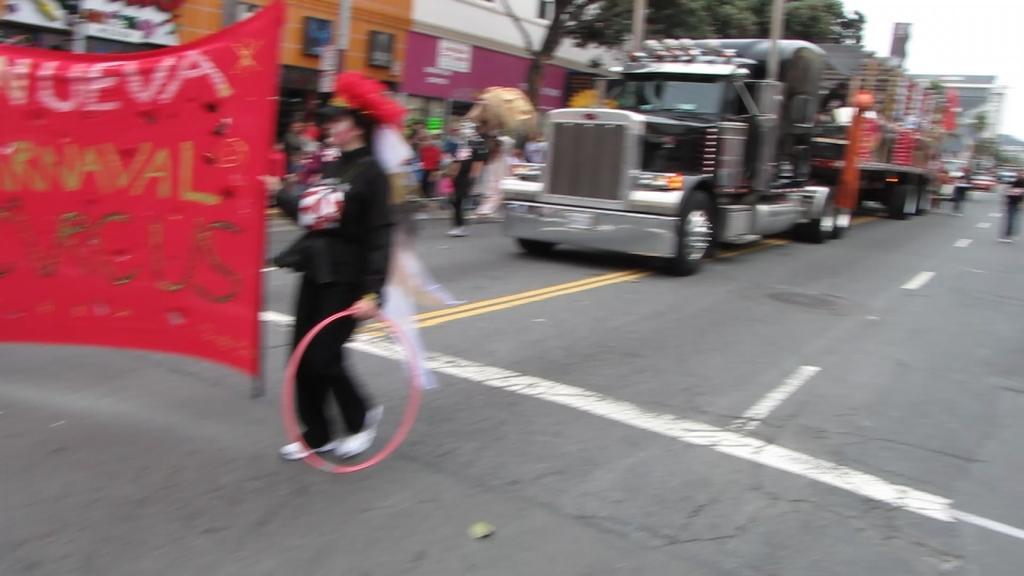In one or two sentences, can you explain what this image depicts? In the image we can see there are people wearing clothes and there are even vehicles on the road. Here we can see the banner and text on it. There are many buildings and trees. Here we can see the sky and the image is slightly blurred. 